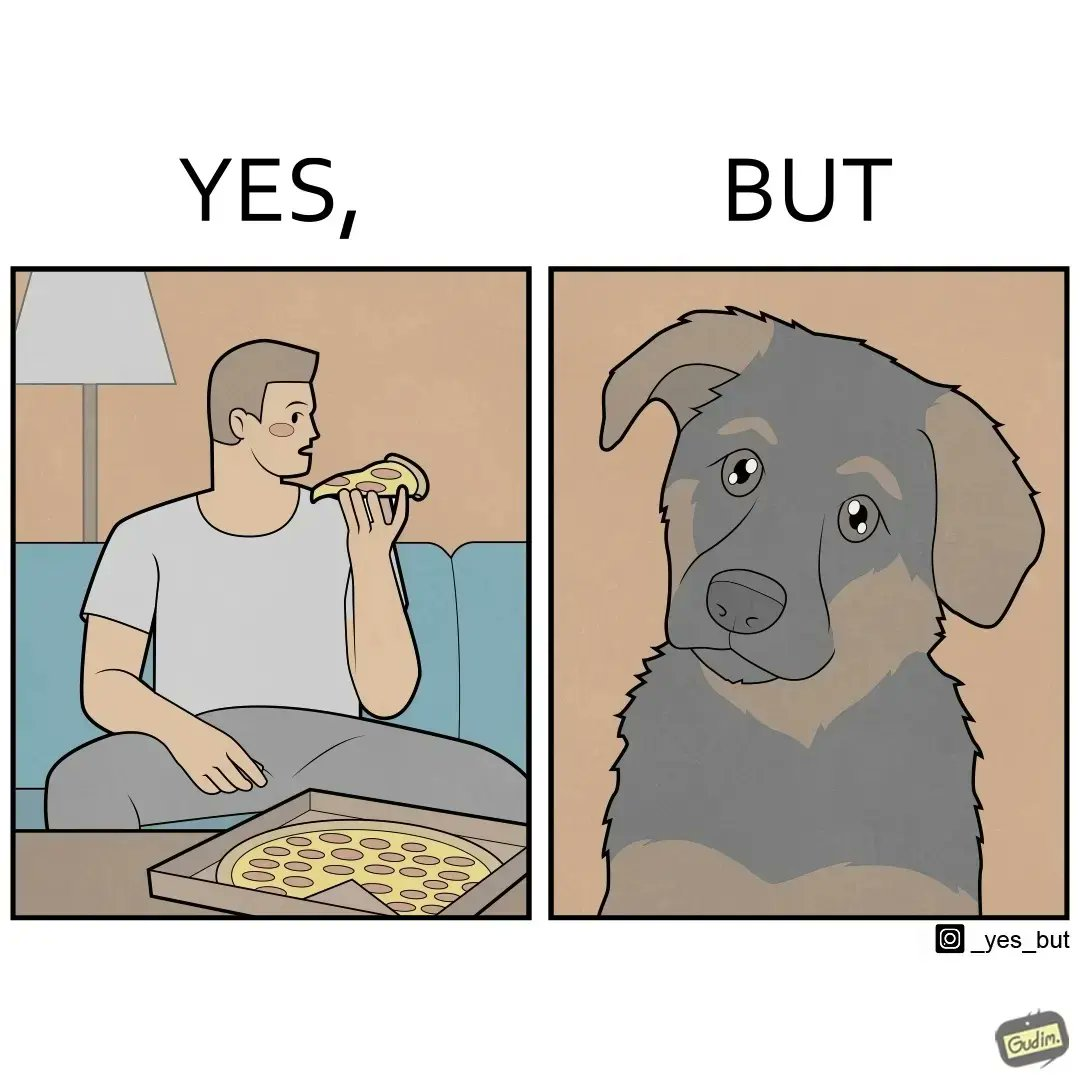What does this image depict? The images are funny since they show how pet owners cannot enjoy any tasty food like pizza without sharing with their pets. The look from the pets makes the owner too guilty if he does not share his food 